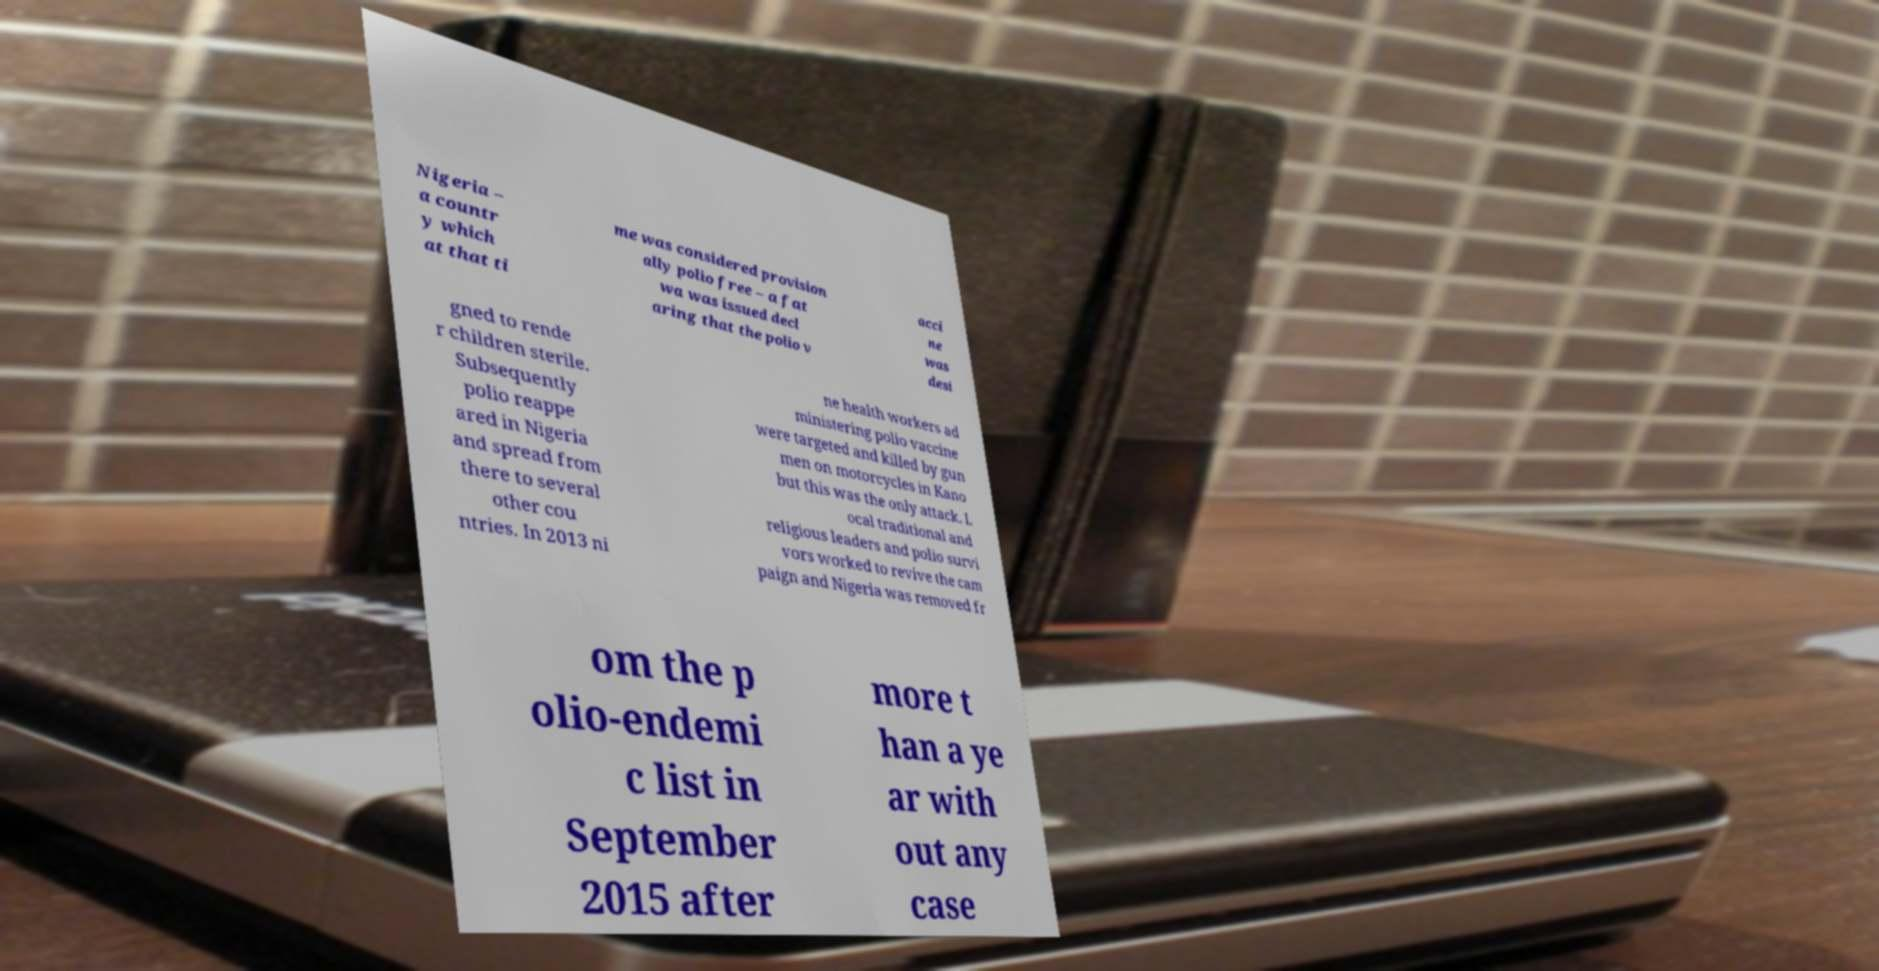Could you assist in decoding the text presented in this image and type it out clearly? Nigeria – a countr y which at that ti me was considered provision ally polio free – a fat wa was issued decl aring that the polio v acci ne was desi gned to rende r children sterile. Subsequently polio reappe ared in Nigeria and spread from there to several other cou ntries. In 2013 ni ne health workers ad ministering polio vaccine were targeted and killed by gun men on motorcycles in Kano but this was the only attack. L ocal traditional and religious leaders and polio survi vors worked to revive the cam paign and Nigeria was removed fr om the p olio-endemi c list in September 2015 after more t han a ye ar with out any case 